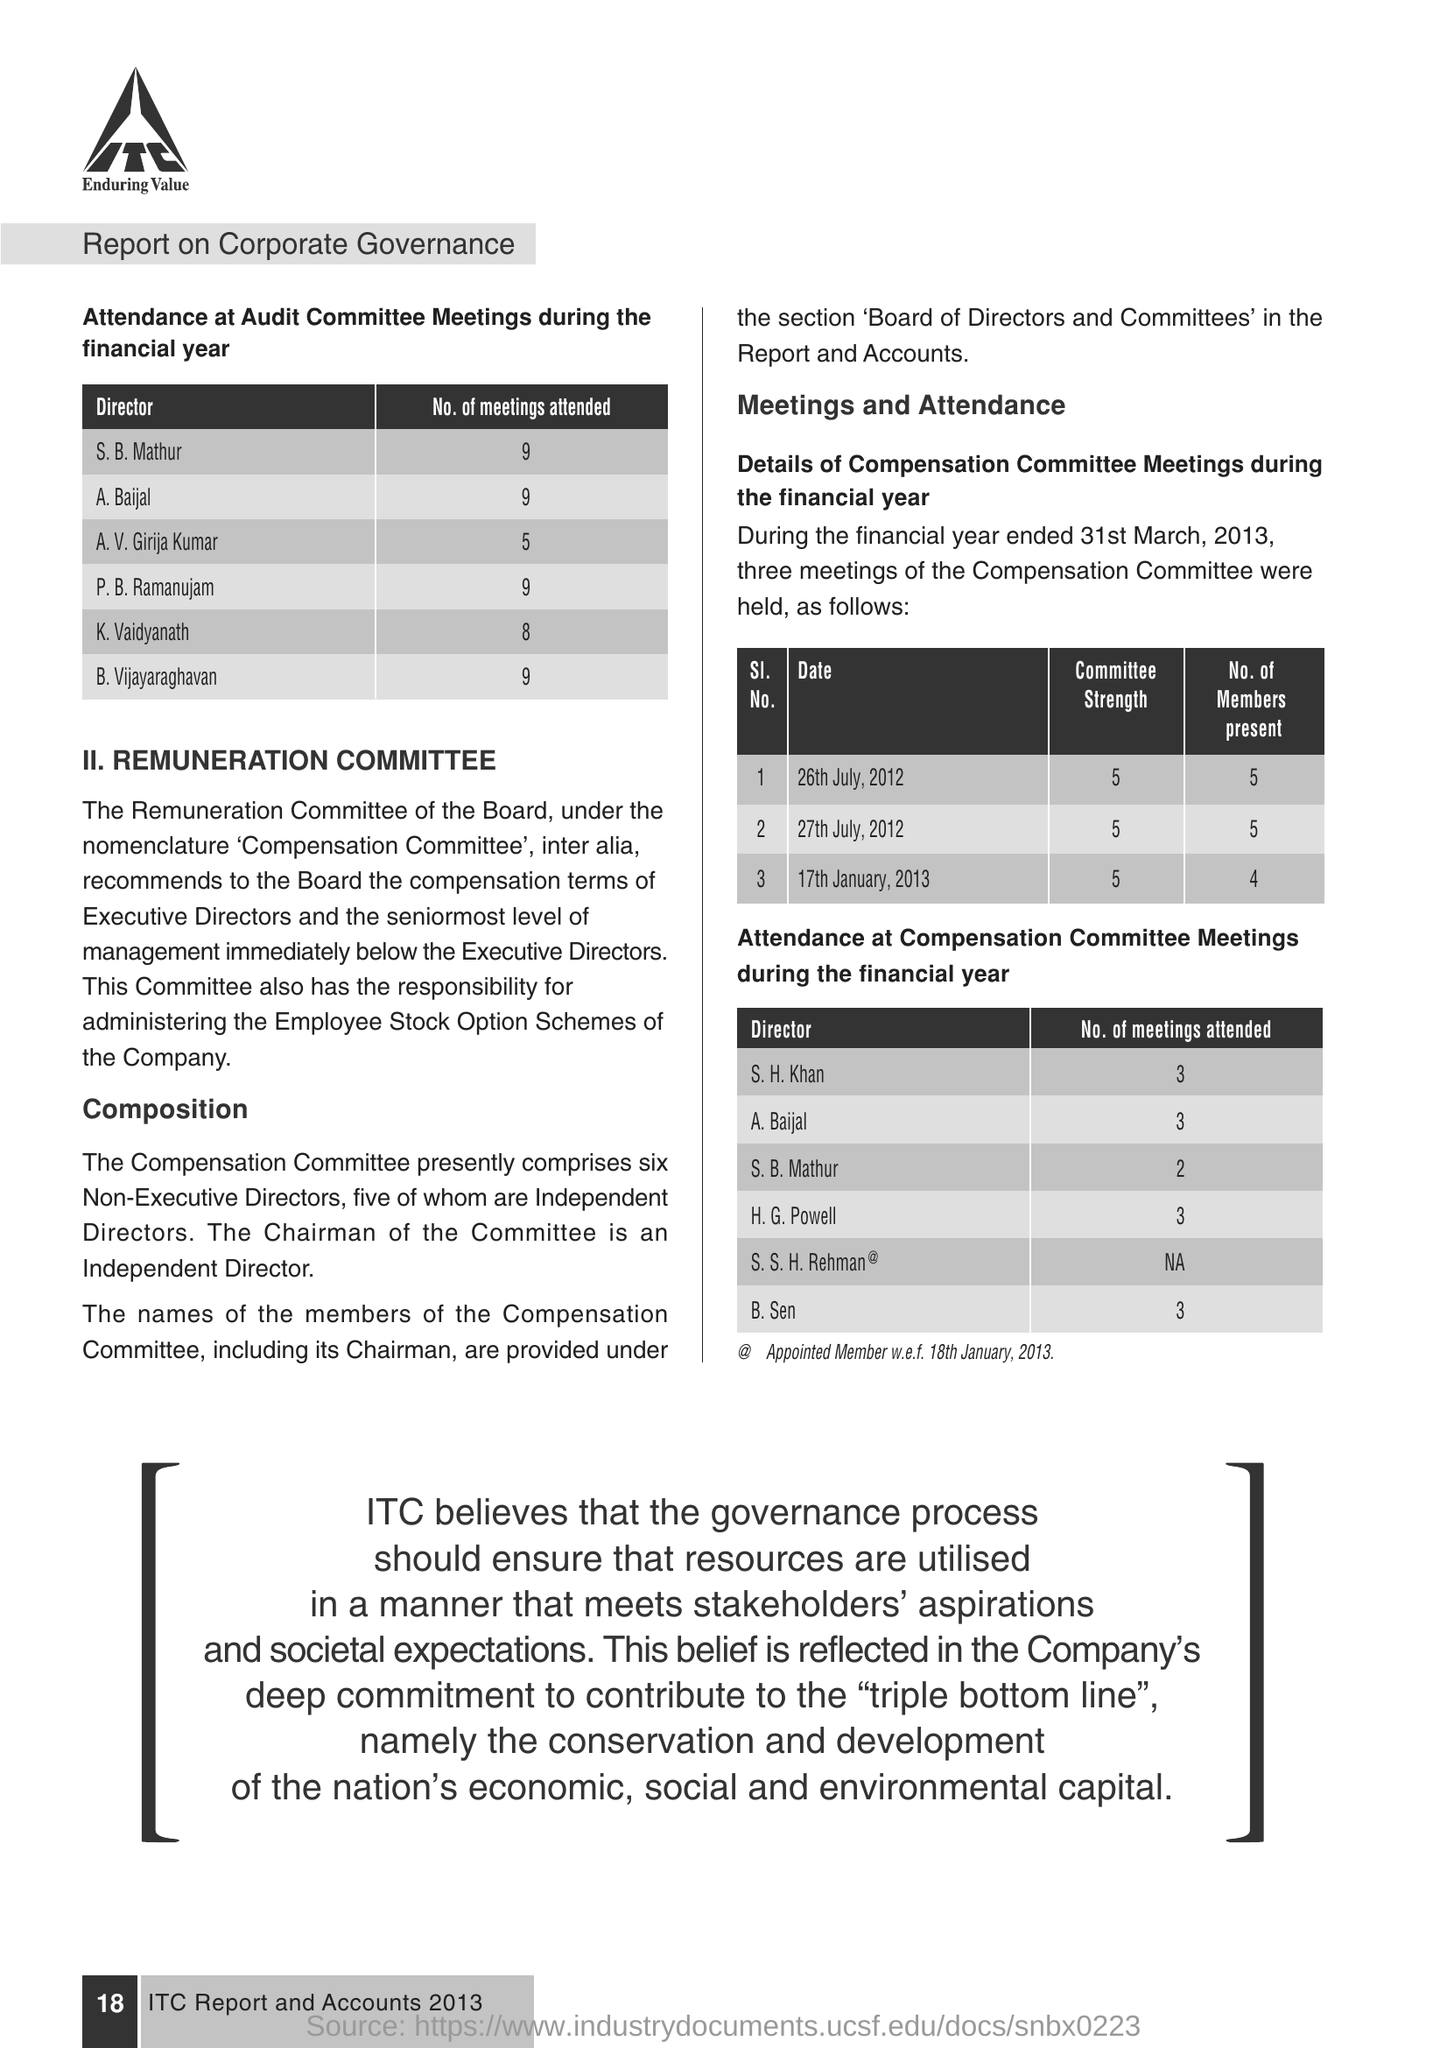Mention a couple of crucial points in this snapshot. During the financial year, three Compensation committee meetings were held. The director, S.B. Mathur, attended 2 compensation committee meetings. During the financial year, K. Vaidyanath attended 8 meetings of the audit committee. 